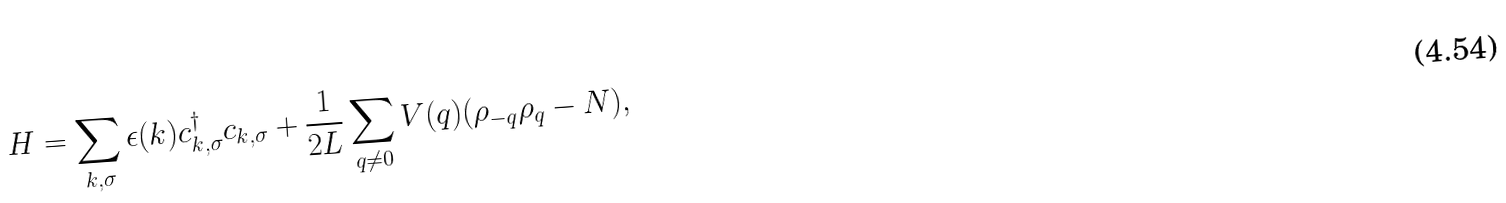Convert formula to latex. <formula><loc_0><loc_0><loc_500><loc_500>H = \sum _ { k , \sigma } \epsilon ( k ) c ^ { \dag } _ { k , \sigma } c _ { k , \sigma } + \frac { 1 } { 2 L } \sum _ { q \ne 0 } V ( q ) ( \rho _ { - q } \rho _ { q } - N ) ,</formula> 